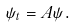<formula> <loc_0><loc_0><loc_500><loc_500>\psi _ { t } = A \psi .</formula> 